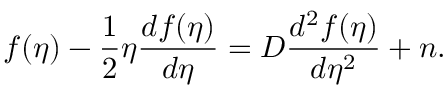<formula> <loc_0><loc_0><loc_500><loc_500>f ( \eta ) - \frac { 1 } { 2 } \eta \frac { d f ( \eta ) } { d \eta } = D \frac { d ^ { 2 } f ( \eta ) } { d \eta ^ { 2 } } + n .</formula> 